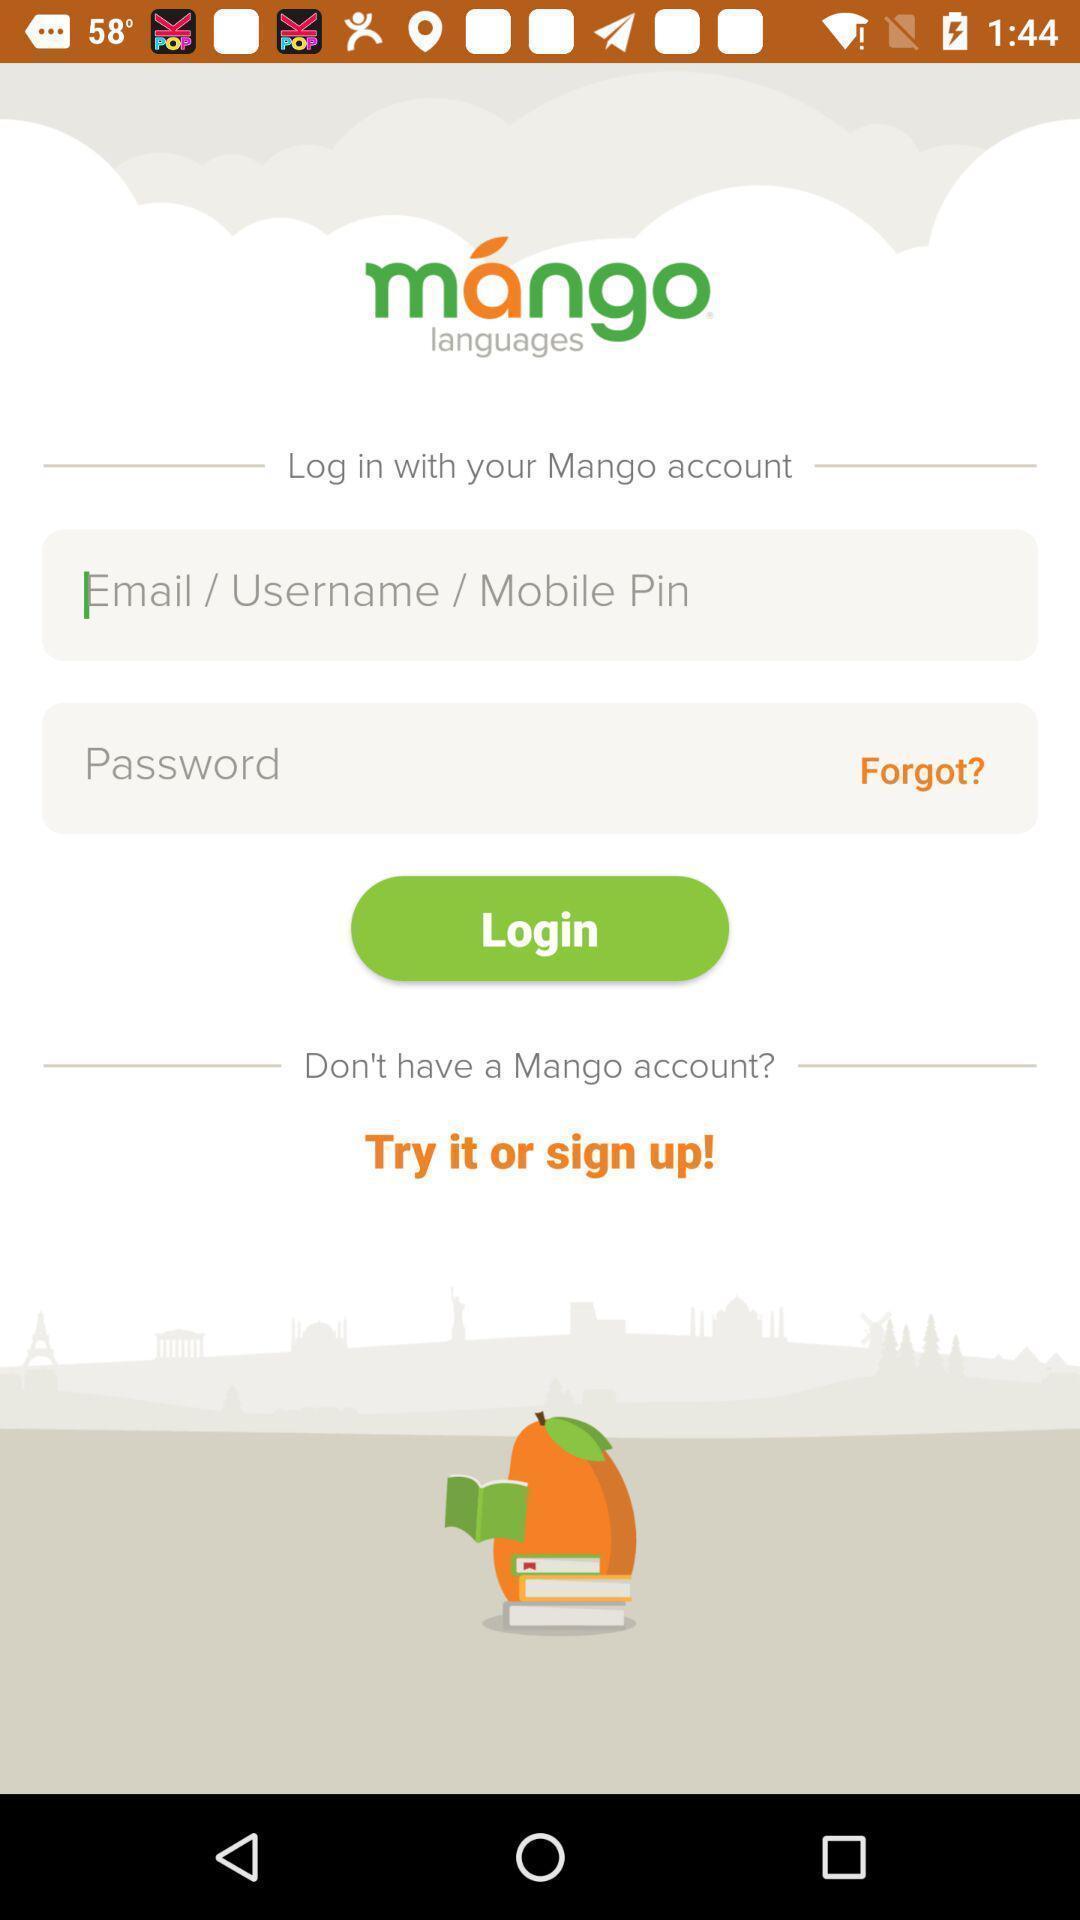Tell me what you see in this picture. Welcome page of a language learning application. 